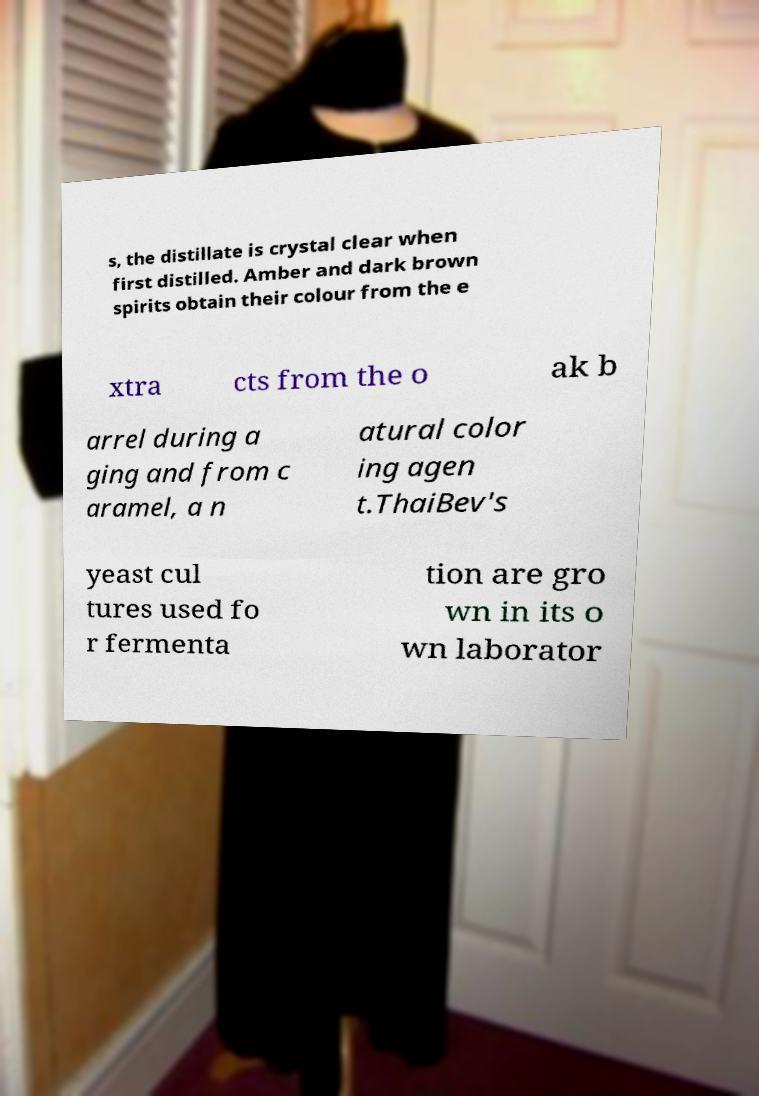Can you accurately transcribe the text from the provided image for me? s, the distillate is crystal clear when first distilled. Amber and dark brown spirits obtain their colour from the e xtra cts from the o ak b arrel during a ging and from c aramel, a n atural color ing agen t.ThaiBev's yeast cul tures used fo r fermenta tion are gro wn in its o wn laborator 